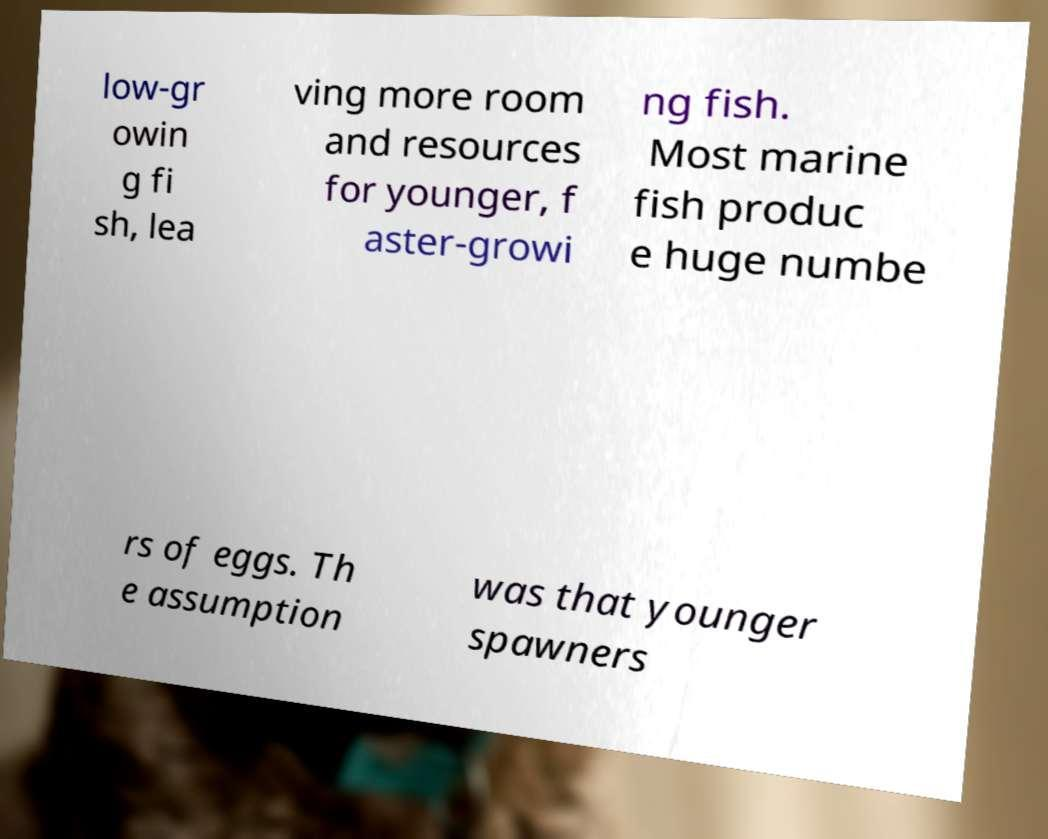Can you read and provide the text displayed in the image?This photo seems to have some interesting text. Can you extract and type it out for me? low-gr owin g fi sh, lea ving more room and resources for younger, f aster-growi ng fish. Most marine fish produc e huge numbe rs of eggs. Th e assumption was that younger spawners 